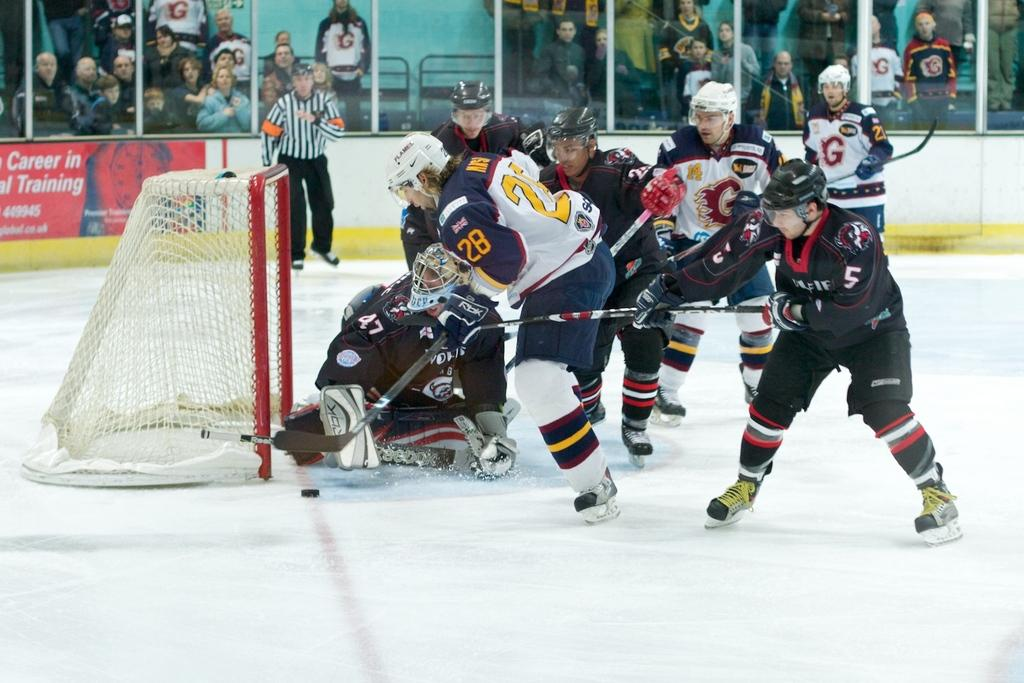<image>
Offer a succinct explanation of the picture presented. a hockey game played in front of an ad about "Career in Training" 